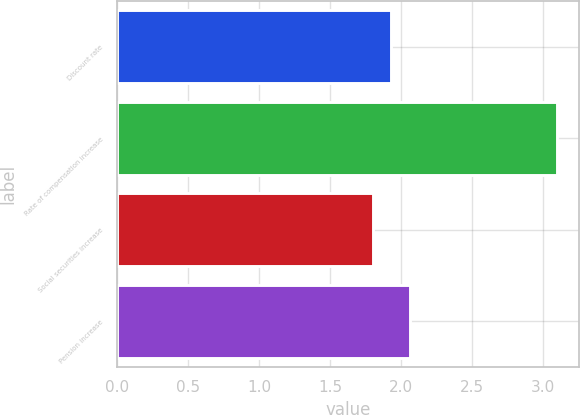Convert chart. <chart><loc_0><loc_0><loc_500><loc_500><bar_chart><fcel>Discount rate<fcel>Rate of compensation increase<fcel>Social securities increase<fcel>Pension increase<nl><fcel>1.93<fcel>3.1<fcel>1.8<fcel>2.06<nl></chart> 